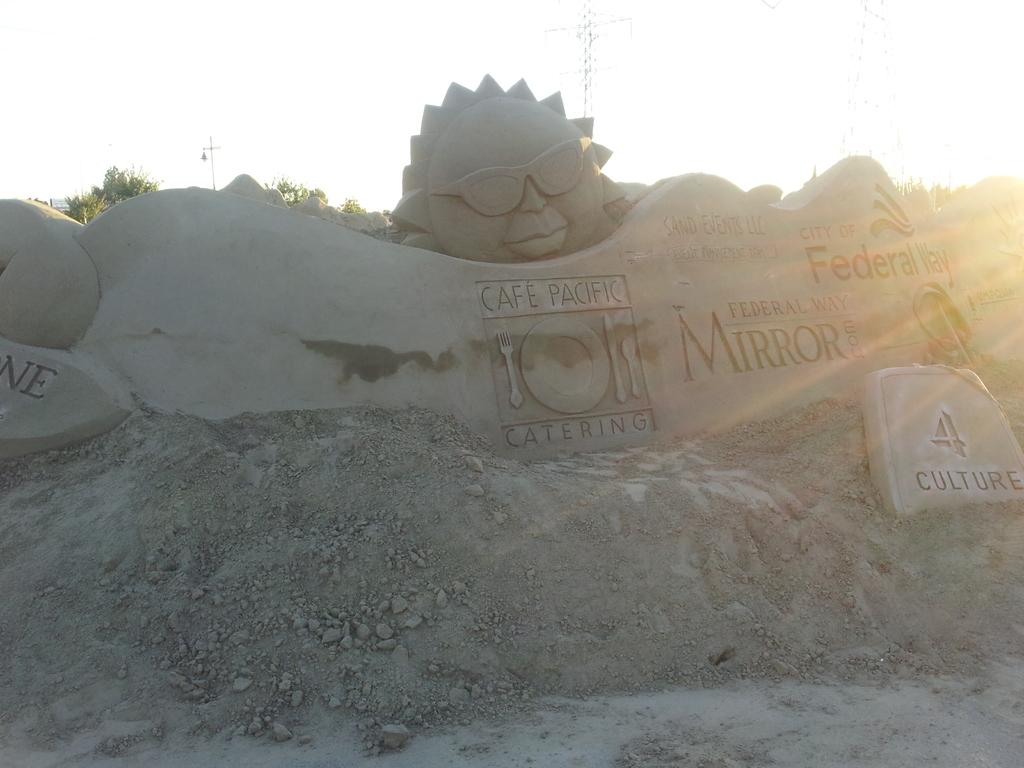What is the main subject of the image? There is a sand sculpture in the image. What can be seen on the sand sculpture? The sand sculpture has some text on it. What type of natural environment is visible in the background of the image? There are trees in the background of the image. What else can be seen in the background of the image? The sky is visible in the background of the image. What type of advice is the minister giving in the image? There is no minister present in the image, and therefore no advice-giving can be observed. 